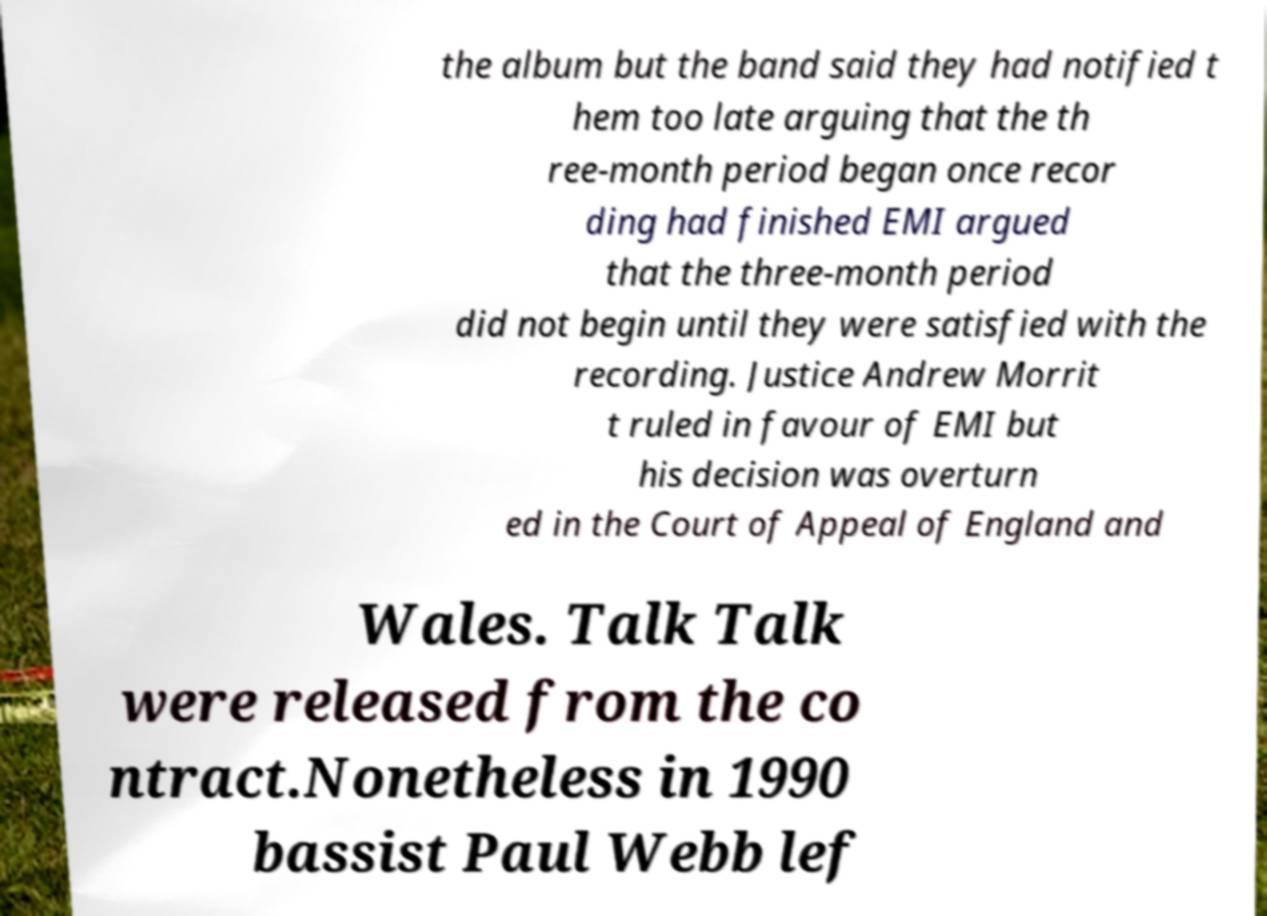Could you extract and type out the text from this image? the album but the band said they had notified t hem too late arguing that the th ree-month period began once recor ding had finished EMI argued that the three-month period did not begin until they were satisfied with the recording. Justice Andrew Morrit t ruled in favour of EMI but his decision was overturn ed in the Court of Appeal of England and Wales. Talk Talk were released from the co ntract.Nonetheless in 1990 bassist Paul Webb lef 